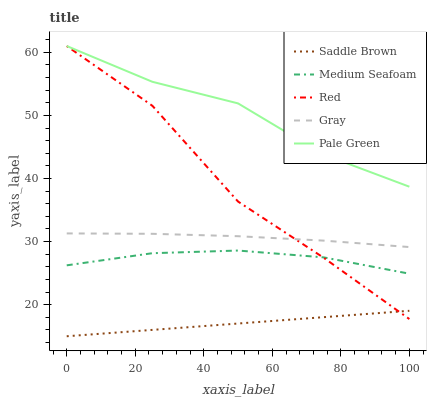Does Saddle Brown have the minimum area under the curve?
Answer yes or no. Yes. Does Pale Green have the minimum area under the curve?
Answer yes or no. No. Does Saddle Brown have the maximum area under the curve?
Answer yes or no. No. Is Pale Green the smoothest?
Answer yes or no. No. Is Pale Green the roughest?
Answer yes or no. No. Does Pale Green have the lowest value?
Answer yes or no. No. Does Saddle Brown have the highest value?
Answer yes or no. No. Is Gray less than Pale Green?
Answer yes or no. Yes. Is Pale Green greater than Medium Seafoam?
Answer yes or no. Yes. Does Gray intersect Pale Green?
Answer yes or no. No. 